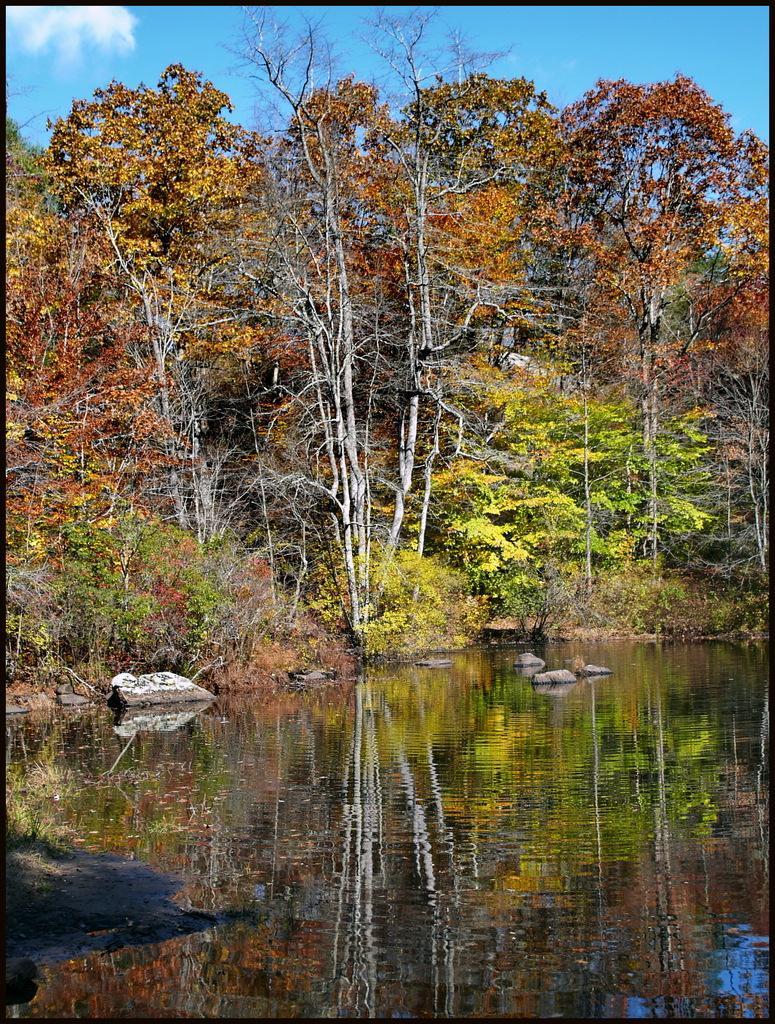Could you give a brief overview of what you see in this image? In this picture I can see many trees, plants and grass. At the bottom I can see the lake. In the center I can see some stones. At the top I can see the sky and clouds. 